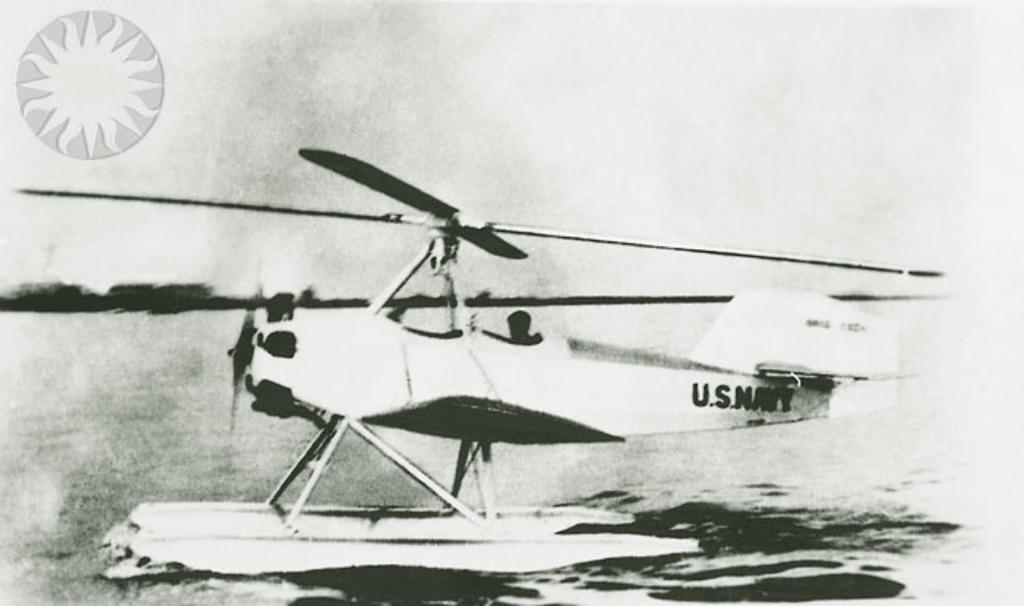What is the color scheme of the image? The image is black and white. What is the main subject of the image? There is a helicopter in the water. Is there any text or symbol present in the image? Yes, there is a logo on the left side of the image. What can be seen in the background of the image? There are trees in the background of the image. What type of eggs are being served by the expert in the image? There is no expert or eggs present in the image. The image features a helicopter in the water, a black and white color scheme, a logo on the left side, and trees in the background. 